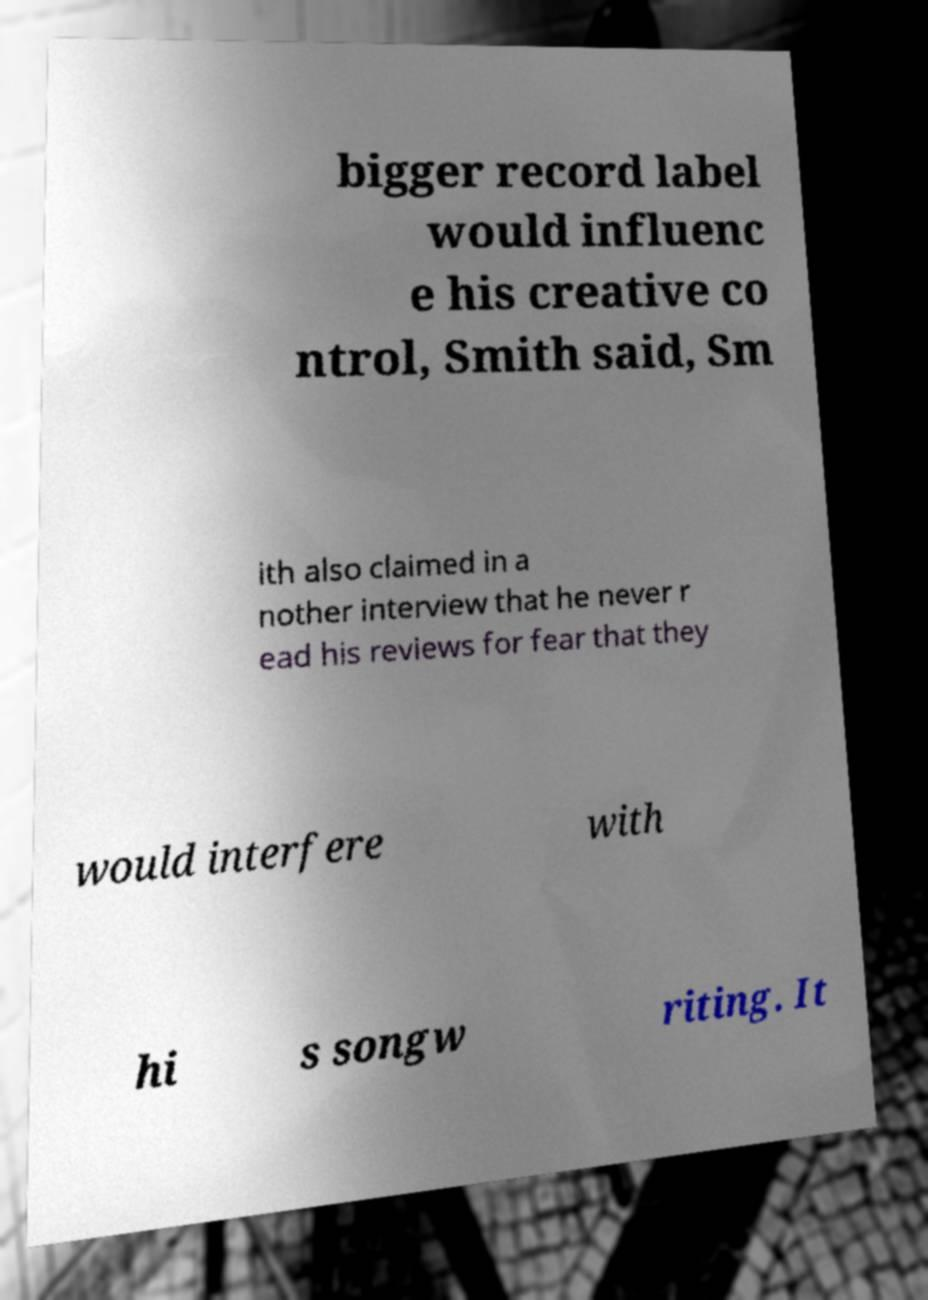Please read and relay the text visible in this image. What does it say? bigger record label would influenc e his creative co ntrol, Smith said, Sm ith also claimed in a nother interview that he never r ead his reviews for fear that they would interfere with hi s songw riting. It 